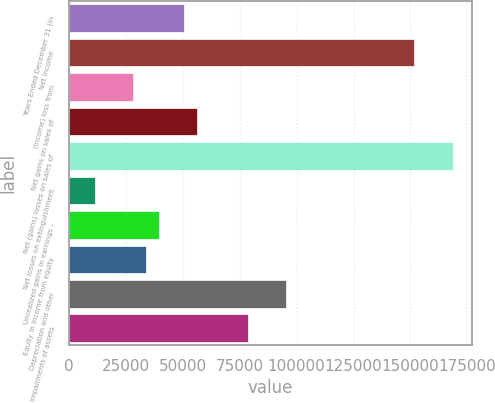Convert chart. <chart><loc_0><loc_0><loc_500><loc_500><bar_chart><fcel>Years Ended December 31 (in<fcel>Net income<fcel>(Income) loss from<fcel>Net gains on sales of<fcel>Net (gains) losses on sales of<fcel>Net losses on extinguishment<fcel>Unrealized gains in earnings -<fcel>Equity in income from equity<fcel>Depreciation and other<fcel>Impairments of assets<nl><fcel>50593.8<fcel>151703<fcel>28125<fcel>56211<fcel>168555<fcel>11273.4<fcel>39359.4<fcel>33742.2<fcel>95531.4<fcel>78679.8<nl></chart> 